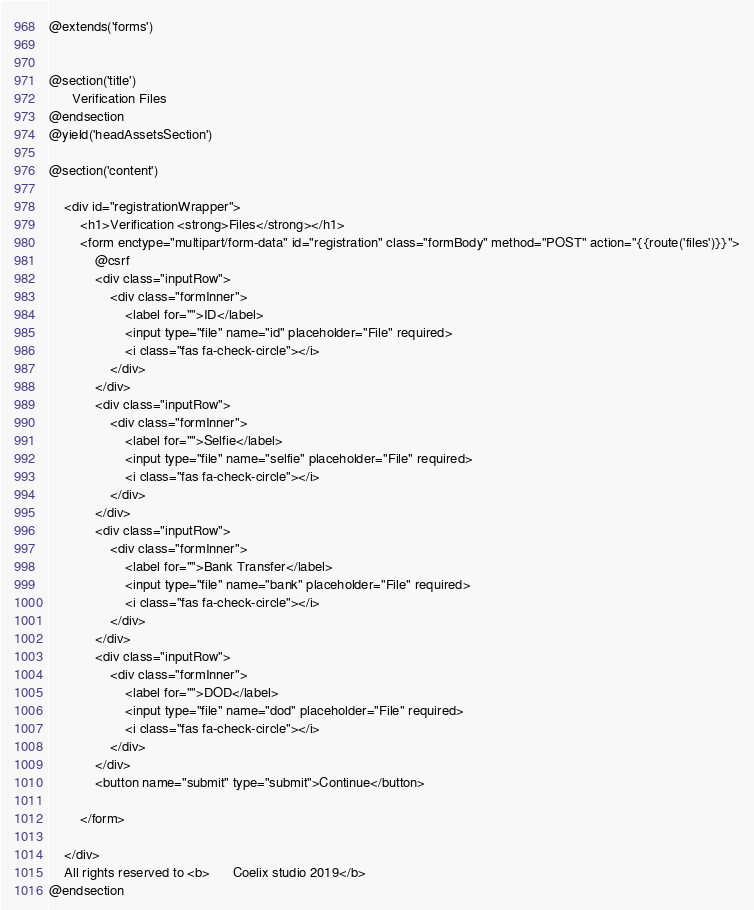Convert code to text. <code><loc_0><loc_0><loc_500><loc_500><_PHP_>@extends('forms')


@section('title')
      Verification Files
@endsection
@yield('headAssetsSection')

@section('content')

    <div id="registrationWrapper">
        <h1>Verification <strong>Files</strong></h1>
        <form enctype="multipart/form-data" id="registration" class="formBody" method="POST" action="{{route('files')}}">
            @csrf
            <div class="inputRow">
                <div class="formInner">
                    <label for="">ID</label>
                    <input type="file" name="id" placeholder="File" required>
                    <i class="fas fa-check-circle"></i>
                </div>
            </div>
            <div class="inputRow">
                <div class="formInner">
                    <label for="">Selfie</label>
                    <input type="file" name="selfie" placeholder="File" required>
                    <i class="fas fa-check-circle"></i>
                </div>
            </div>
            <div class="inputRow">
                <div class="formInner">
                    <label for="">Bank Transfer</label>
                    <input type="file" name="bank" placeholder="File" required>
                    <i class="fas fa-check-circle"></i>
                </div>
            </div>
            <div class="inputRow">
                <div class="formInner">
                    <label for="">DOD</label>
                    <input type="file" name="dod" placeholder="File" required>
                    <i class="fas fa-check-circle"></i>
                </div>
            </div>
            <button name="submit" type="submit">Continue</button>

        </form>

    </div>
    All rights reserved to <b>      Coelix studio 2019</b>
@endsection

</code> 